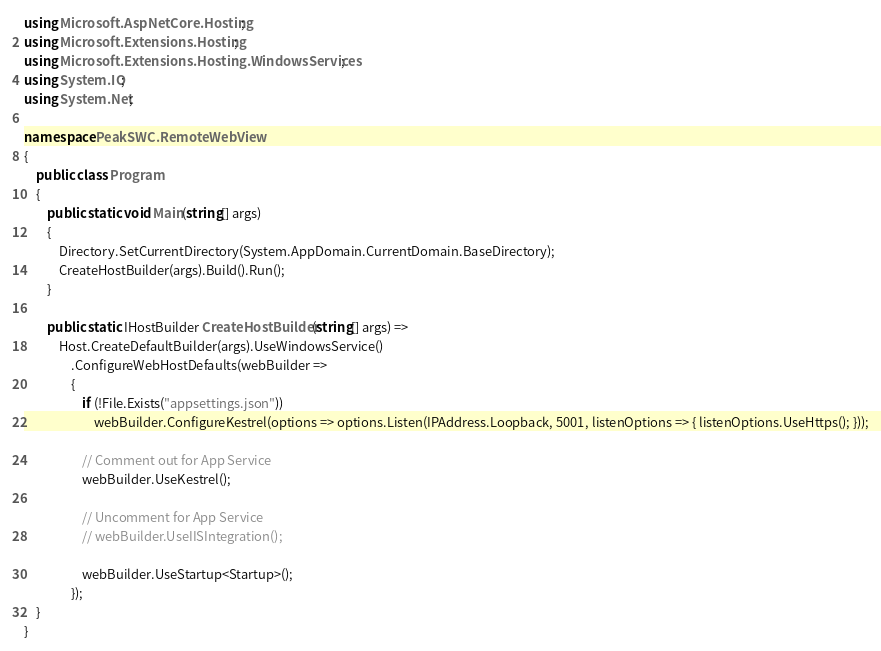<code> <loc_0><loc_0><loc_500><loc_500><_C#_>using Microsoft.AspNetCore.Hosting;
using Microsoft.Extensions.Hosting;
using Microsoft.Extensions.Hosting.WindowsServices;
using System.IO;
using System.Net;

namespace PeakSWC.RemoteWebView
{
    public class Program
    {
        public static void Main(string[] args)
        {
			Directory.SetCurrentDirectory(System.AppDomain.CurrentDomain.BaseDirectory);
            CreateHostBuilder(args).Build().Run();
        }

        public static IHostBuilder CreateHostBuilder(string[] args) =>
            Host.CreateDefaultBuilder(args).UseWindowsService()
                .ConfigureWebHostDefaults(webBuilder =>
                {
                    if (!File.Exists("appsettings.json"))
                        webBuilder.ConfigureKestrel(options => options.Listen(IPAddress.Loopback, 5001, listenOptions => { listenOptions.UseHttps(); }));

                    // Comment out for App Service
                    webBuilder.UseKestrel();

                    // Uncomment for App Service
                    // webBuilder.UseIISIntegration();

                    webBuilder.UseStartup<Startup>();
                });
    }
}
</code> 